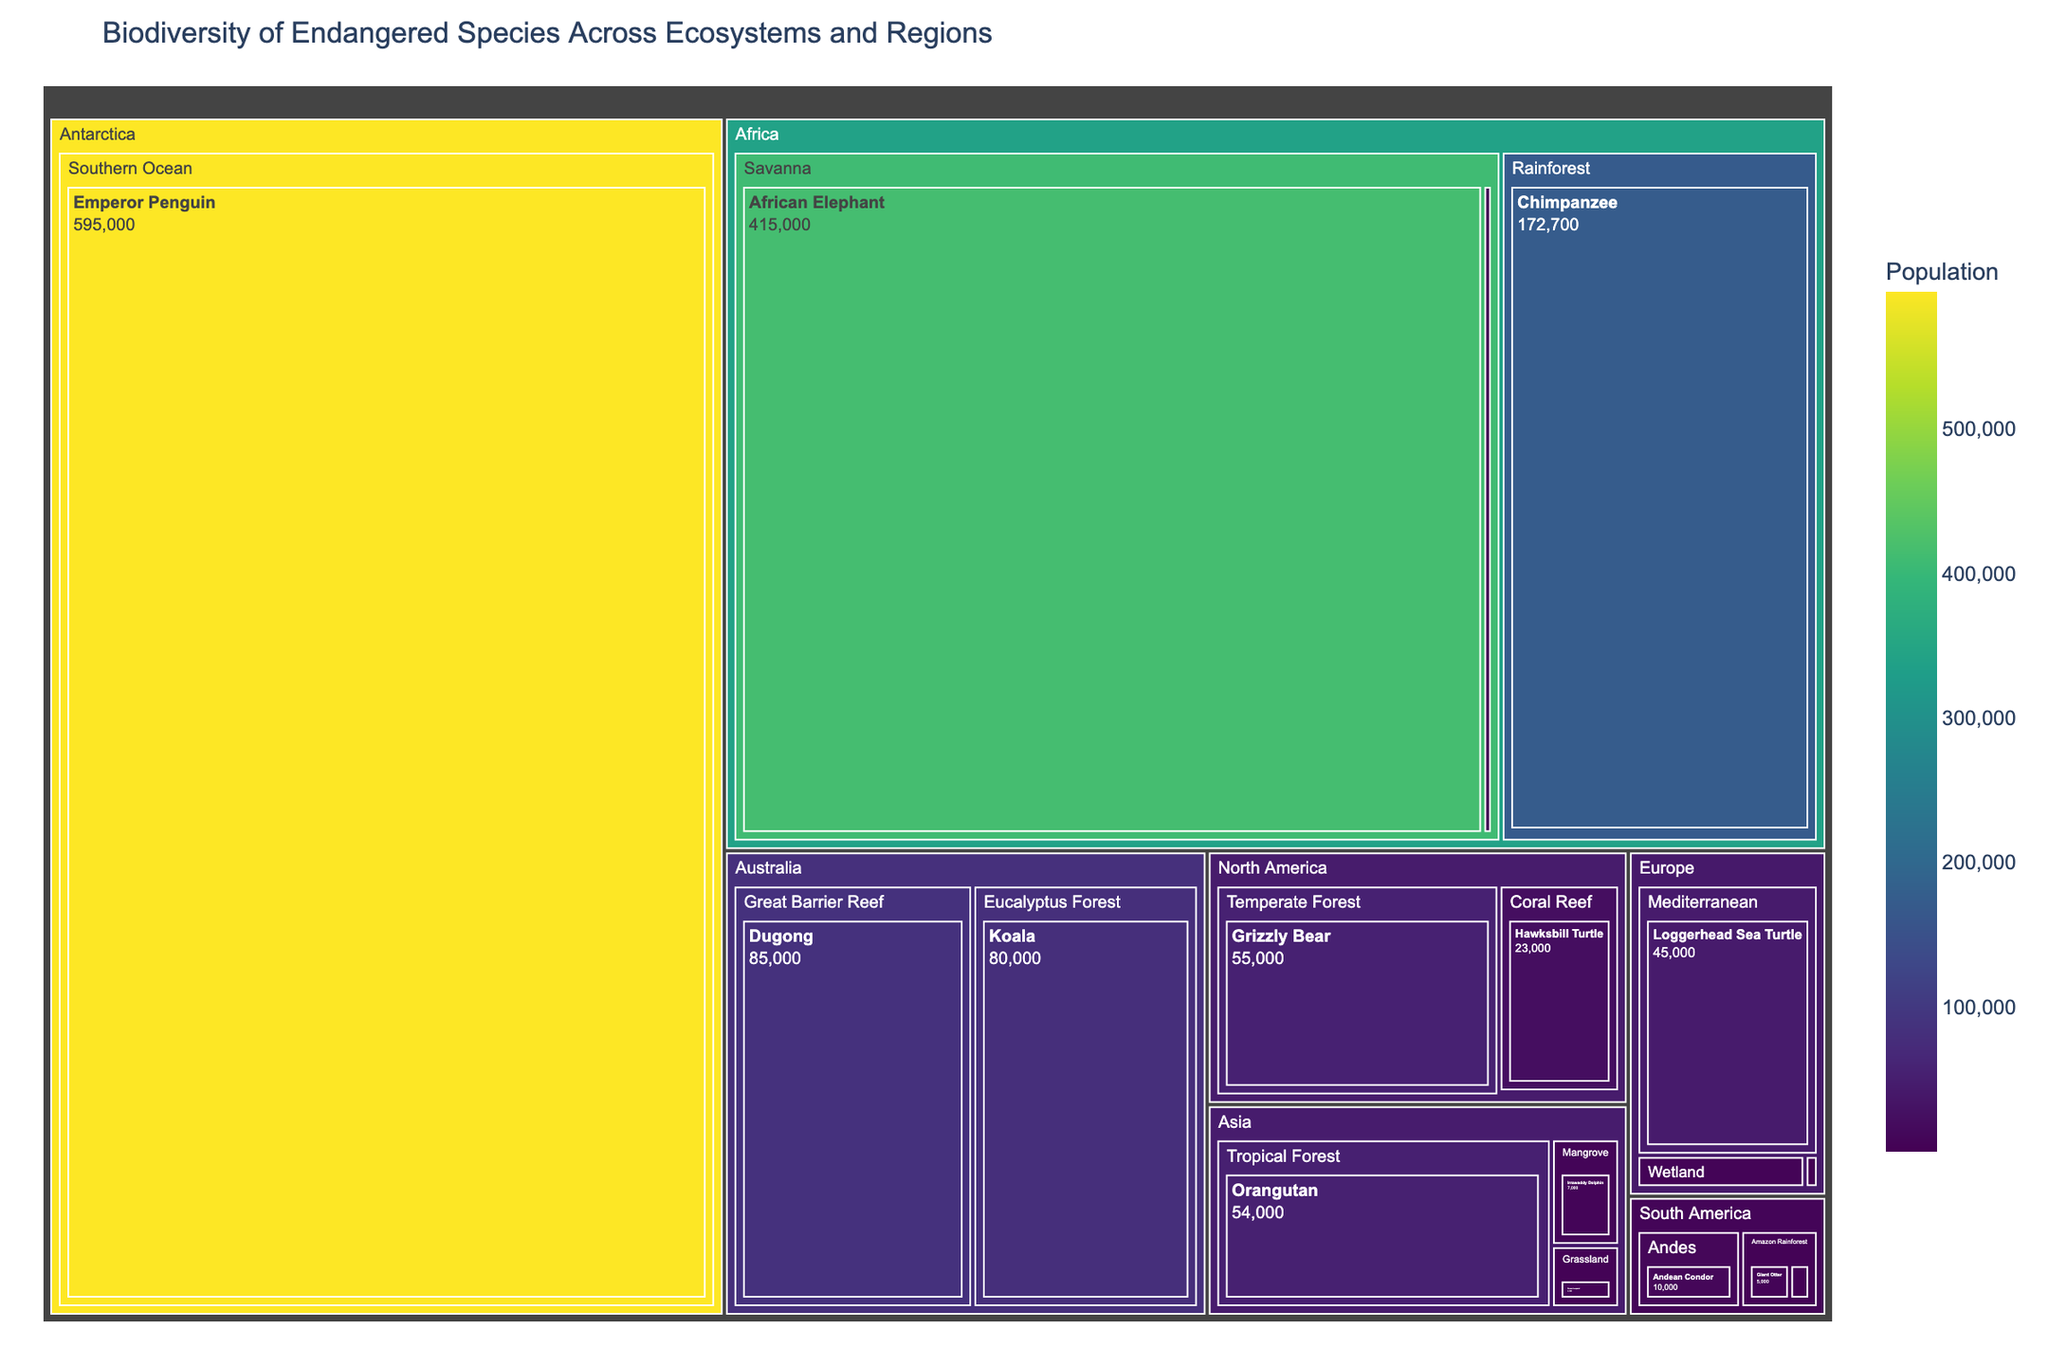Which region has the species with the highest population? The species with the highest population is the Emperor Penguin in Antarctica with a population of 595,000. This can be identified by the largest distinct segment in the treemap.
Answer: Antarctica How many species are depicted in the Savanna ecosystem in Africa? There are two distinct segments within the Savanna ecosystem in Africa in the treemap, representing the African Elephant and the Black Rhino.
Answer: 2 Is the population of the Grizzly Bear in North America greater than the population of the Koala in Australia? The population of the Grizzly Bear in North America is 55,000, while the population of the Koala in Australia is 80,000. Therefore, the population of the Koala is greater than that of the Grizzly Bear.
Answer: No Which ecosystem in Europe has the species with the lowest population? The species with the lowest population in Europe is the Iberian Lynx in the Alpine ecosystem with a population of 400.
Answer: Alpine What is the total population of species in the Amazon Rainforest of South America? The Amazon Rainforest in South America has the Giant Otter with a population of 5,000 and the Golden Lion Tamarin with a population of 2,500. The total population is 7,500 (5,000 + 2,500).
Answer: 7,500 How does the population of the Dugong in Australia compare to that of the African Elephant in Africa? The population of the Dugong in Australia is 85,000, while the population of the African Elephant in Africa is 415,000. Therefore, the population of the African Elephant is greater than that of the Dugong.
Answer: The population of the African Elephant is greater Which species has a higher population in Asia: the Sumatran Tiger or the Orangutan? In Asia, the population of the Orangutan is 54,000, whereas the population of the Sumatran Tiger is 400. Therefore, the population of the Orangutan is higher.
Answer: Orangutan What is the combined population of species in Africa's Rainforest ecosystem? Africa's Rainforest ecosystem has the Mountain Gorilla with a population of 1,000 and the Chimpanzee with 172,700. The combined population is 173,700 (1,000 + 172,700).
Answer: 173,700 Which region has the most ecosystems represented in the treemap? By observing the distinct segments representing ecosystems within each region, it is clear that Asia has the most ecosystems (Tropical Forest, Mangrove, Grassland).
Answer: Asia 